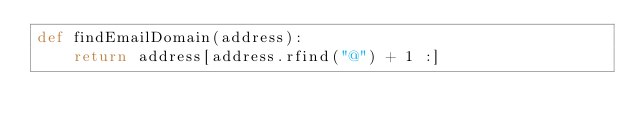<code> <loc_0><loc_0><loc_500><loc_500><_Python_>def findEmailDomain(address):
    return address[address.rfind("@") + 1 :]
</code> 